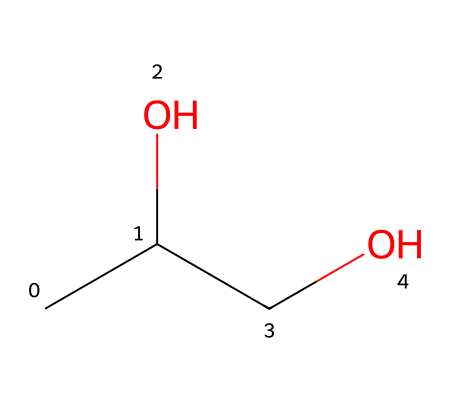What is the IUPAC name of this chemical? The chemical structure represented by the SMILES CC(O)CO corresponds to a molecule with two carbon atoms and a hydroxyl group. Hence, its IUPAC name is propylene glycol.
Answer: propylene glycol How many carbon atoms are present in this chemical? Analyzing the SMILES representation CC(O)CO reveals that there are three carbon atoms in total since there are three 'C' atoms present in the sequence.
Answer: three What type of functional groups does this chemical contain? The presence of the 'O' in the structure indicates the existence of hydroxyl groups (-OH), which are characteristic of alcohols.
Answer: alcohols What is the molecular formula of this chemical? The chemical has three carbon atoms, eight hydrogen atoms, and two oxygen atoms. Therefore, the molecular formula can be written as C3H8O2.
Answer: C3H8O2 How would you classify this chemical in terms of its use? Given its ability to inhibit microbial growth while being safe for consumption, this chemical serves as a food preservative as well as a coolant.
Answer: preservative 